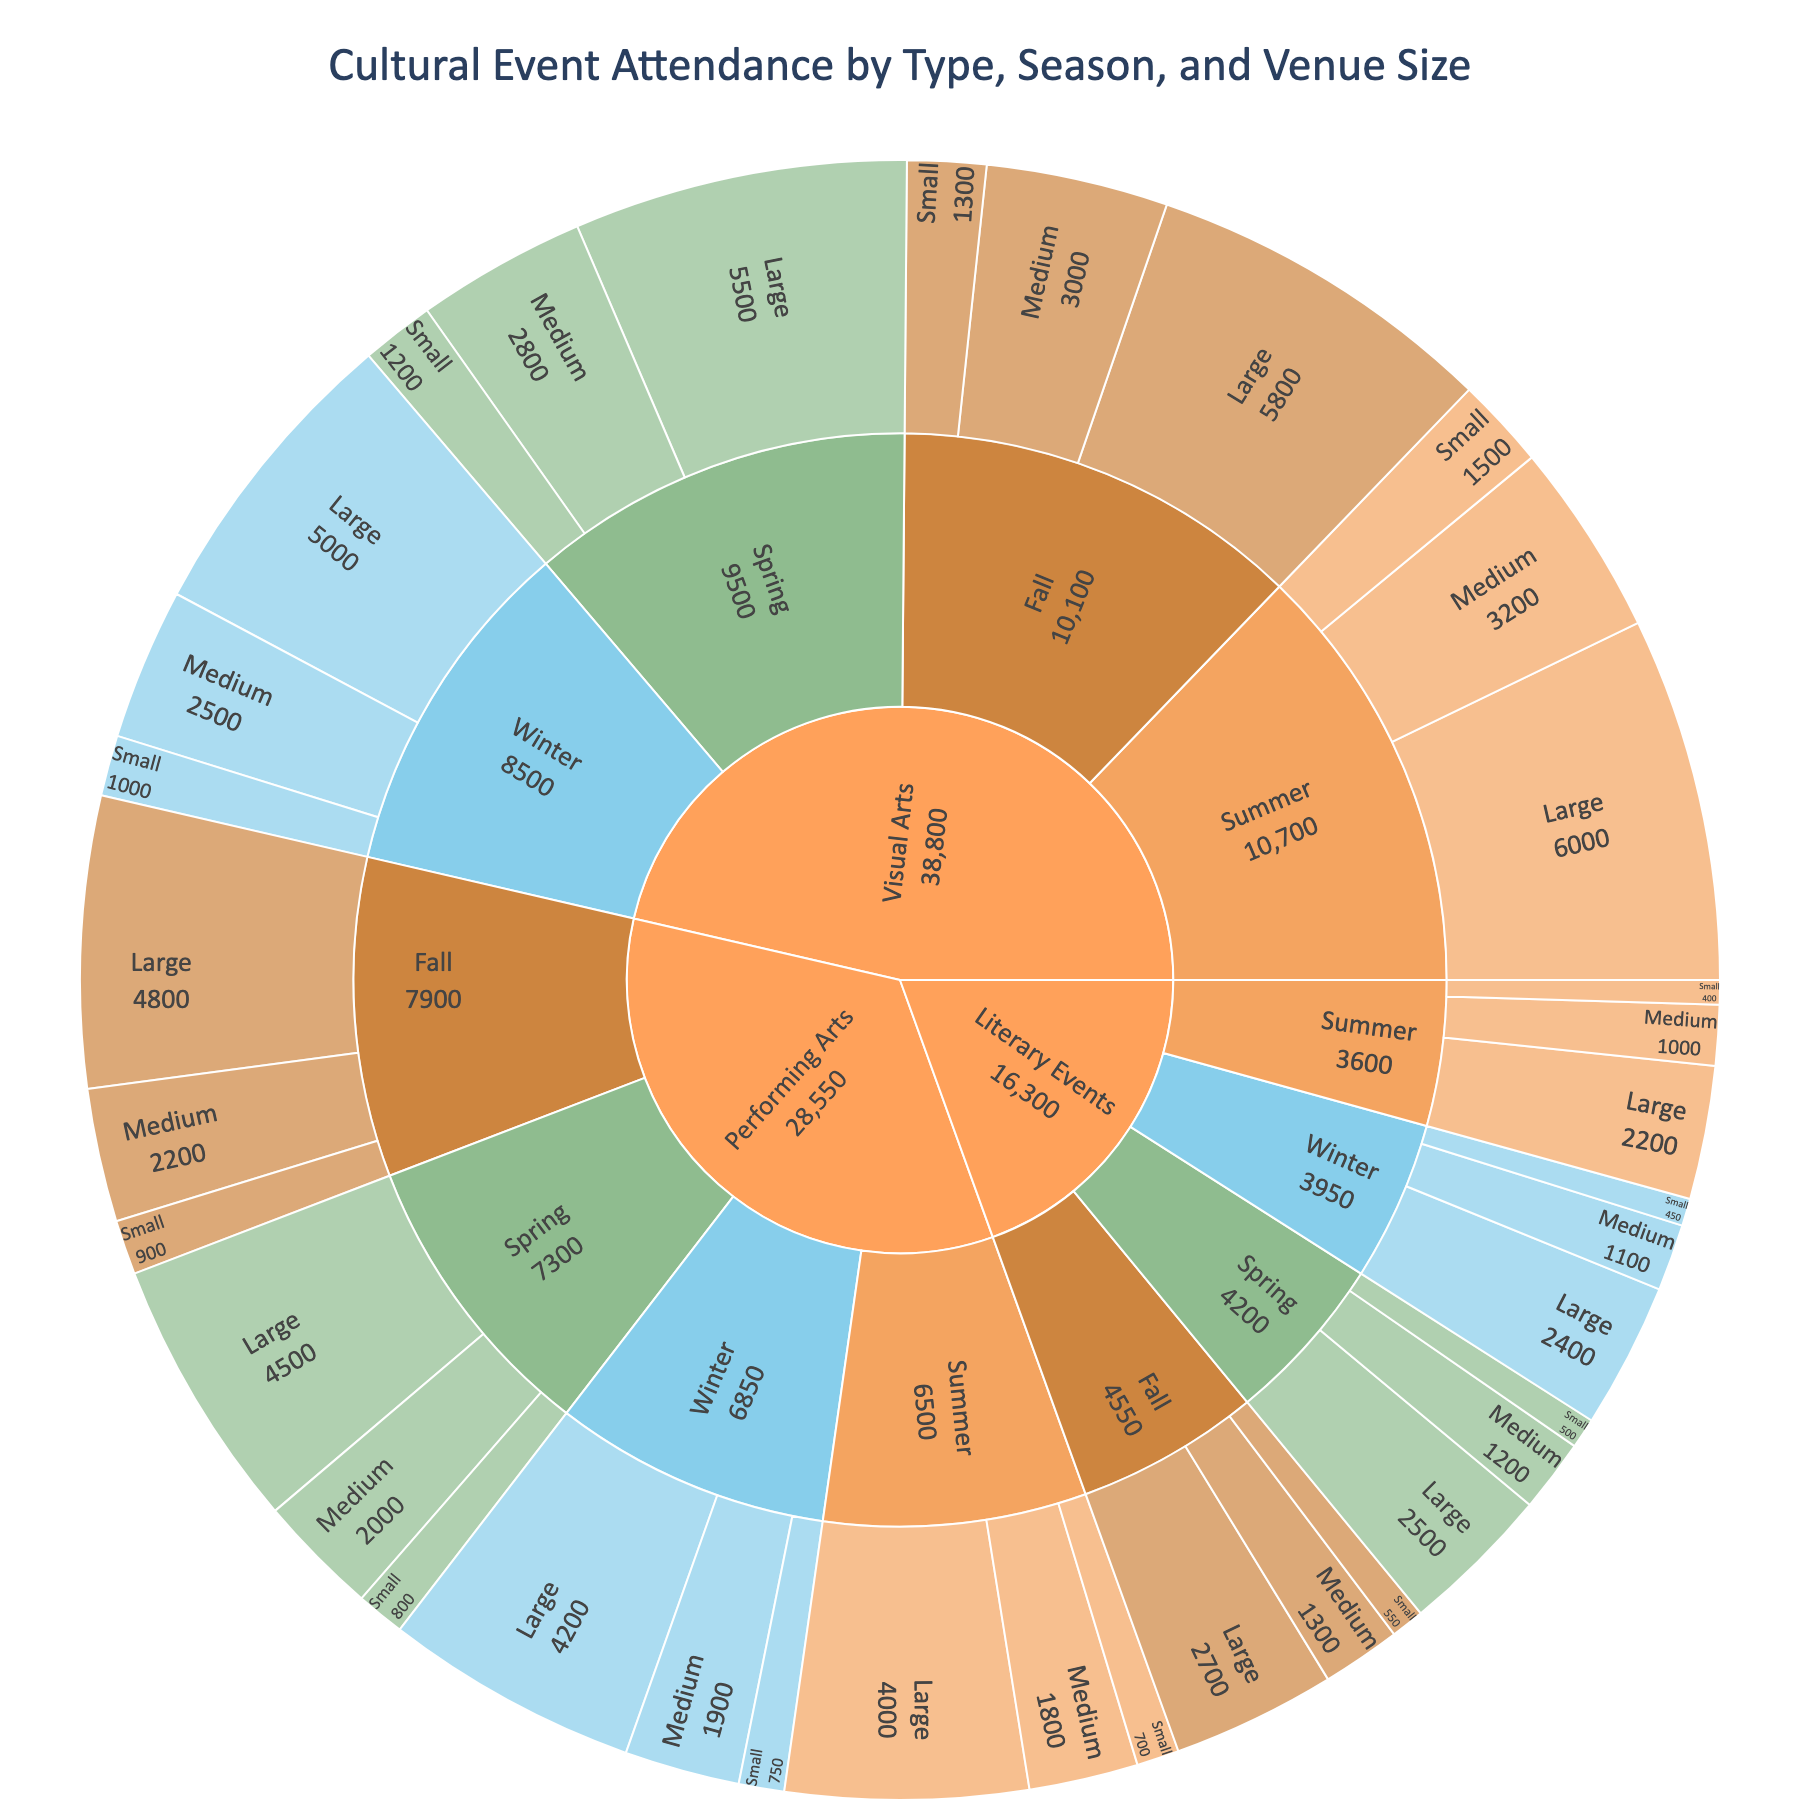What's the title of the figure? The title is prominently displayed at the top of the figure, indicating what the data represents.
Answer: Cultural Event Attendance by Type, Season, and Venue Size Which season has the highest attendance for Visual Arts events in large venues? Follow the path from Visual Arts to each season and then to large venues. The attendance for large venues in each Visual Arts season is displayed.
Answer: Summer How does the attendance at Winter Performing Arts events compare to Fall Performing Arts events across medium-sized venues? Follow the Performing Arts path to Winter and Fall, and then compare the attendance in medium venues.
Answer: Winter has 1900 attendees, Fall has 2200 attendees; Fall has higher attendance What's the total attendance for all Visual Arts events in the Spring season? Sum the attendance values for small, medium, and large venues under Visual Arts in the Spring season: 1200 + 2800 + 5500.
Answer: 9500 What is the difference in attendance between small and large venue Winter Literary Events? Compare the attendance between small (450) and large (2400) venues under Winter Literary Events. The difference is calculated as 2400 - 450.
Answer: 1950 Compare the total attendance for Small venues in Fall across all event types. Which type has the highest? Sum the attendance for all event types in Fall, small venues: Visual Arts (1300), Performing Arts (900), Literary Events (550). Compare these totals.
Answer: Visual Arts with 1300 What's the least attended combination of season and venue size for Literary Events? Navigate through Literary Events to each season and venue size, comparing attendance values.
Answer: Summer, Small (400) Which season has the most balanced attendance across all types and venue sizes? Check the attendance distribution across different event types and venue sizes for each season to find the most even spread.
Answer: Fall Find the largest variance in attendance across venue sizes within a single season for Performing Arts. Extract attendance for Performing Arts across different seasons and venue sizes, then calculate the variance in each season.
Answer: Spring (from 800 small to 4500 large) Comparing Visual Arts and Literary Events, which event type has a higher overall attendance in medium venues during Spring? Navigate through Visual Arts and Literary Events paths to Spring and medium venues, then compare their attendance.
Answer: Visual Arts with 2800 